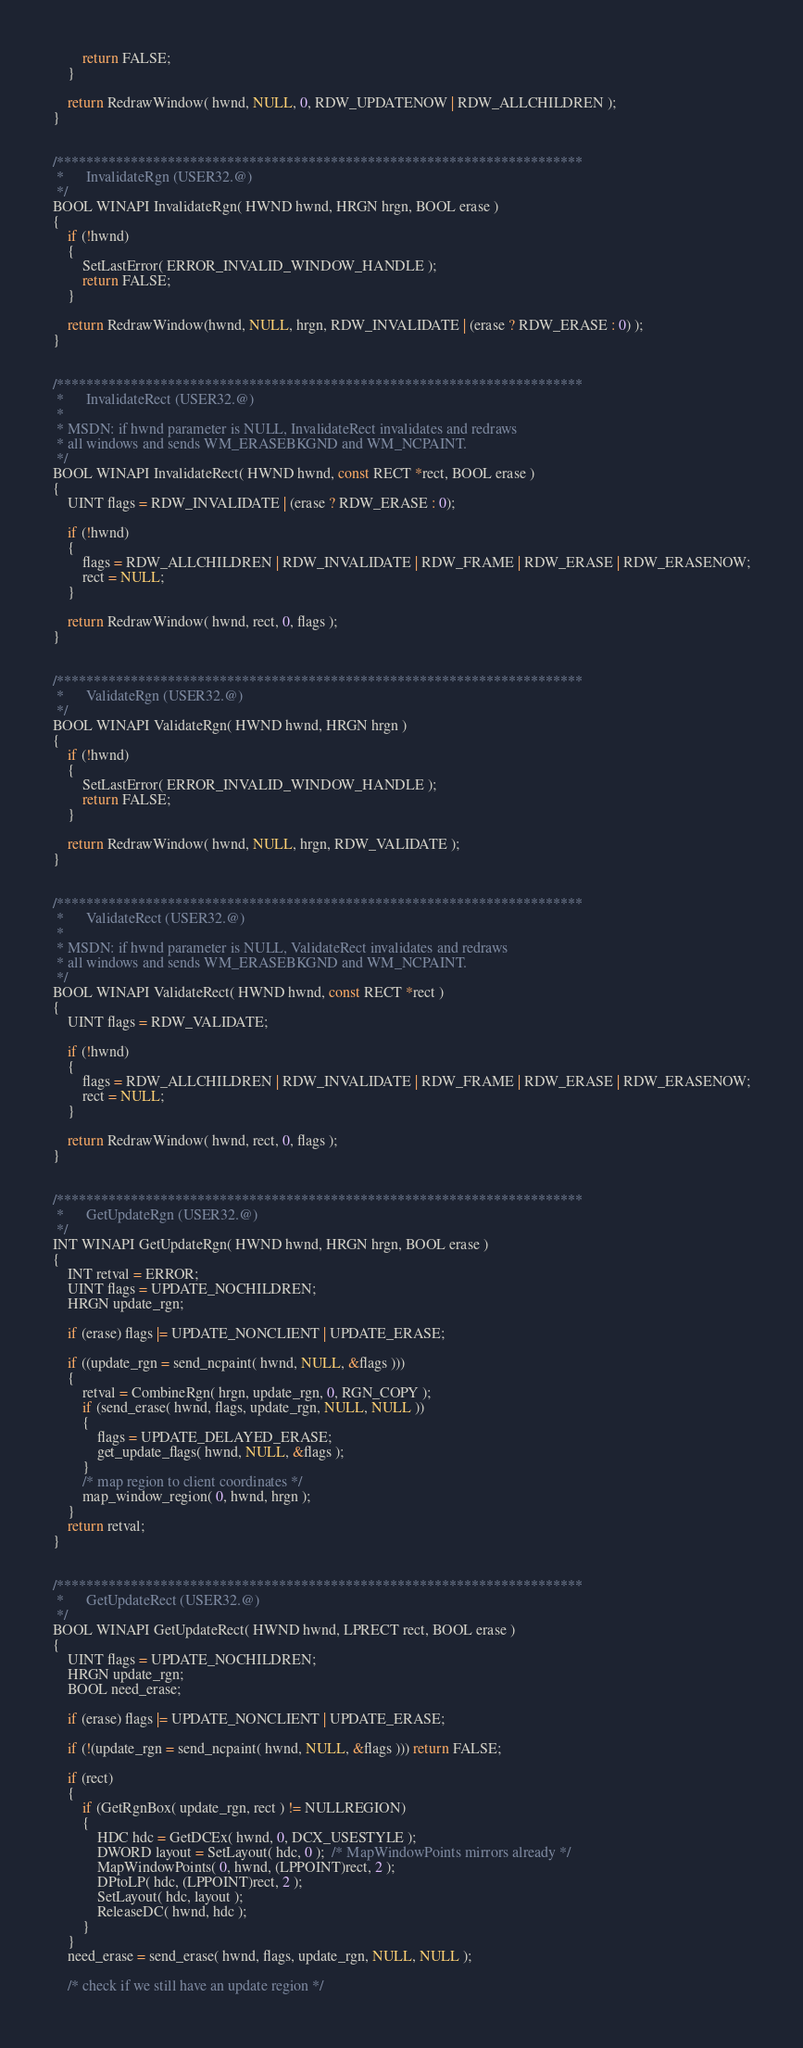Convert code to text. <code><loc_0><loc_0><loc_500><loc_500><_C_>        return FALSE;
    }

    return RedrawWindow( hwnd, NULL, 0, RDW_UPDATENOW | RDW_ALLCHILDREN );
}


/***********************************************************************
 *		InvalidateRgn (USER32.@)
 */
BOOL WINAPI InvalidateRgn( HWND hwnd, HRGN hrgn, BOOL erase )
{
    if (!hwnd)
    {
        SetLastError( ERROR_INVALID_WINDOW_HANDLE );
        return FALSE;
    }

    return RedrawWindow(hwnd, NULL, hrgn, RDW_INVALIDATE | (erase ? RDW_ERASE : 0) );
}


/***********************************************************************
 *		InvalidateRect (USER32.@)
 *
 * MSDN: if hwnd parameter is NULL, InvalidateRect invalidates and redraws
 * all windows and sends WM_ERASEBKGND and WM_NCPAINT.
 */
BOOL WINAPI InvalidateRect( HWND hwnd, const RECT *rect, BOOL erase )
{
    UINT flags = RDW_INVALIDATE | (erase ? RDW_ERASE : 0);

    if (!hwnd)
    {
        flags = RDW_ALLCHILDREN | RDW_INVALIDATE | RDW_FRAME | RDW_ERASE | RDW_ERASENOW;
        rect = NULL;
    }

    return RedrawWindow( hwnd, rect, 0, flags );
}


/***********************************************************************
 *		ValidateRgn (USER32.@)
 */
BOOL WINAPI ValidateRgn( HWND hwnd, HRGN hrgn )
{
    if (!hwnd)
    {
        SetLastError( ERROR_INVALID_WINDOW_HANDLE );
        return FALSE;
    }

    return RedrawWindow( hwnd, NULL, hrgn, RDW_VALIDATE );
}


/***********************************************************************
 *		ValidateRect (USER32.@)
 *
 * MSDN: if hwnd parameter is NULL, ValidateRect invalidates and redraws
 * all windows and sends WM_ERASEBKGND and WM_NCPAINT.
 */
BOOL WINAPI ValidateRect( HWND hwnd, const RECT *rect )
{
    UINT flags = RDW_VALIDATE;

    if (!hwnd)
    {
        flags = RDW_ALLCHILDREN | RDW_INVALIDATE | RDW_FRAME | RDW_ERASE | RDW_ERASENOW;
        rect = NULL;
    }

    return RedrawWindow( hwnd, rect, 0, flags );
}


/***********************************************************************
 *		GetUpdateRgn (USER32.@)
 */
INT WINAPI GetUpdateRgn( HWND hwnd, HRGN hrgn, BOOL erase )
{
    INT retval = ERROR;
    UINT flags = UPDATE_NOCHILDREN;
    HRGN update_rgn;

    if (erase) flags |= UPDATE_NONCLIENT | UPDATE_ERASE;

    if ((update_rgn = send_ncpaint( hwnd, NULL, &flags )))
    {
        retval = CombineRgn( hrgn, update_rgn, 0, RGN_COPY );
        if (send_erase( hwnd, flags, update_rgn, NULL, NULL ))
        {
            flags = UPDATE_DELAYED_ERASE;
            get_update_flags( hwnd, NULL, &flags );
        }
        /* map region to client coordinates */
        map_window_region( 0, hwnd, hrgn );
    }
    return retval;
}


/***********************************************************************
 *		GetUpdateRect (USER32.@)
 */
BOOL WINAPI GetUpdateRect( HWND hwnd, LPRECT rect, BOOL erase )
{
    UINT flags = UPDATE_NOCHILDREN;
    HRGN update_rgn;
    BOOL need_erase;

    if (erase) flags |= UPDATE_NONCLIENT | UPDATE_ERASE;

    if (!(update_rgn = send_ncpaint( hwnd, NULL, &flags ))) return FALSE;

    if (rect)
    {
        if (GetRgnBox( update_rgn, rect ) != NULLREGION)
        {
            HDC hdc = GetDCEx( hwnd, 0, DCX_USESTYLE );
            DWORD layout = SetLayout( hdc, 0 );  /* MapWindowPoints mirrors already */
            MapWindowPoints( 0, hwnd, (LPPOINT)rect, 2 );
            DPtoLP( hdc, (LPPOINT)rect, 2 );
            SetLayout( hdc, layout );
            ReleaseDC( hwnd, hdc );
        }
    }
    need_erase = send_erase( hwnd, flags, update_rgn, NULL, NULL );

    /* check if we still have an update region */</code> 